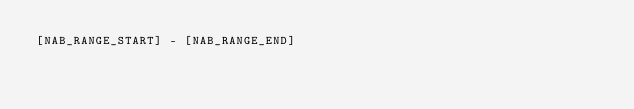<code> <loc_0><loc_0><loc_500><loc_500><_Perl_>[NAB_RANGE_START] - [NAB_RANGE_END]</code> 